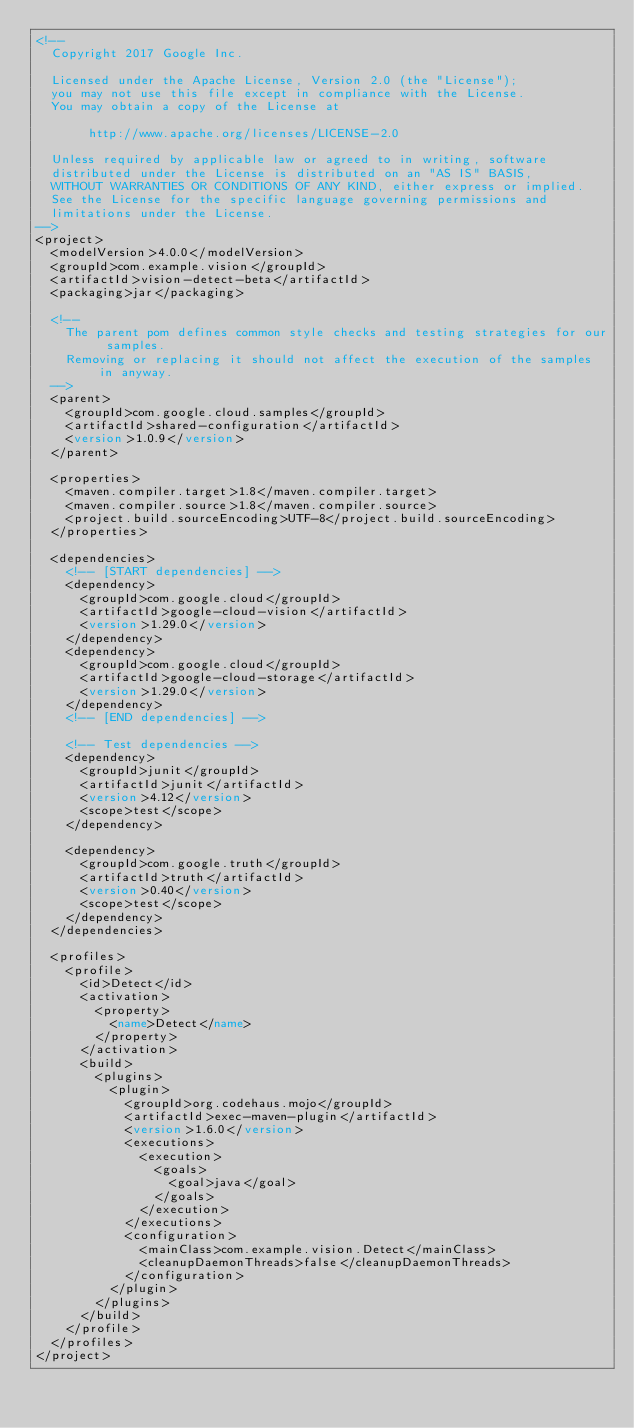Convert code to text. <code><loc_0><loc_0><loc_500><loc_500><_XML_><!--
  Copyright 2017 Google Inc.

  Licensed under the Apache License, Version 2.0 (the "License");
  you may not use this file except in compliance with the License.
  You may obtain a copy of the License at

       http://www.apache.org/licenses/LICENSE-2.0

  Unless required by applicable law or agreed to in writing, software
  distributed under the License is distributed on an "AS IS" BASIS,
  WITHOUT WARRANTIES OR CONDITIONS OF ANY KIND, either express or implied.
  See the License for the specific language governing permissions and
  limitations under the License.
-->
<project>
  <modelVersion>4.0.0</modelVersion>
  <groupId>com.example.vision</groupId>
  <artifactId>vision-detect-beta</artifactId>
  <packaging>jar</packaging>

  <!--
    The parent pom defines common style checks and testing strategies for our samples.
    Removing or replacing it should not affect the execution of the samples in anyway.
  -->
  <parent>
    <groupId>com.google.cloud.samples</groupId>
    <artifactId>shared-configuration</artifactId>
    <version>1.0.9</version>
  </parent>

  <properties>
    <maven.compiler.target>1.8</maven.compiler.target>
    <maven.compiler.source>1.8</maven.compiler.source>
    <project.build.sourceEncoding>UTF-8</project.build.sourceEncoding>
  </properties>

  <dependencies>
    <!-- [START dependencies] -->
    <dependency>
      <groupId>com.google.cloud</groupId>
      <artifactId>google-cloud-vision</artifactId>
      <version>1.29.0</version>
    </dependency>
    <dependency>
      <groupId>com.google.cloud</groupId>
      <artifactId>google-cloud-storage</artifactId>
      <version>1.29.0</version>
    </dependency>
    <!-- [END dependencies] -->

    <!-- Test dependencies -->
    <dependency>
      <groupId>junit</groupId>
      <artifactId>junit</artifactId>
      <version>4.12</version>
      <scope>test</scope>
    </dependency>

    <dependency>
      <groupId>com.google.truth</groupId>
      <artifactId>truth</artifactId>
      <version>0.40</version>
      <scope>test</scope>
    </dependency>
  </dependencies>

  <profiles>
    <profile>
      <id>Detect</id>
      <activation>
        <property>
          <name>Detect</name>
        </property>
      </activation>
      <build>
        <plugins>
          <plugin>
            <groupId>org.codehaus.mojo</groupId>
            <artifactId>exec-maven-plugin</artifactId>
            <version>1.6.0</version>
            <executions>
              <execution>
                <goals>
                  <goal>java</goal>
                </goals>
              </execution>
            </executions>
            <configuration>
              <mainClass>com.example.vision.Detect</mainClass>
              <cleanupDaemonThreads>false</cleanupDaemonThreads>
            </configuration>
          </plugin>
        </plugins>
      </build>
    </profile>
  </profiles>
</project>
</code> 